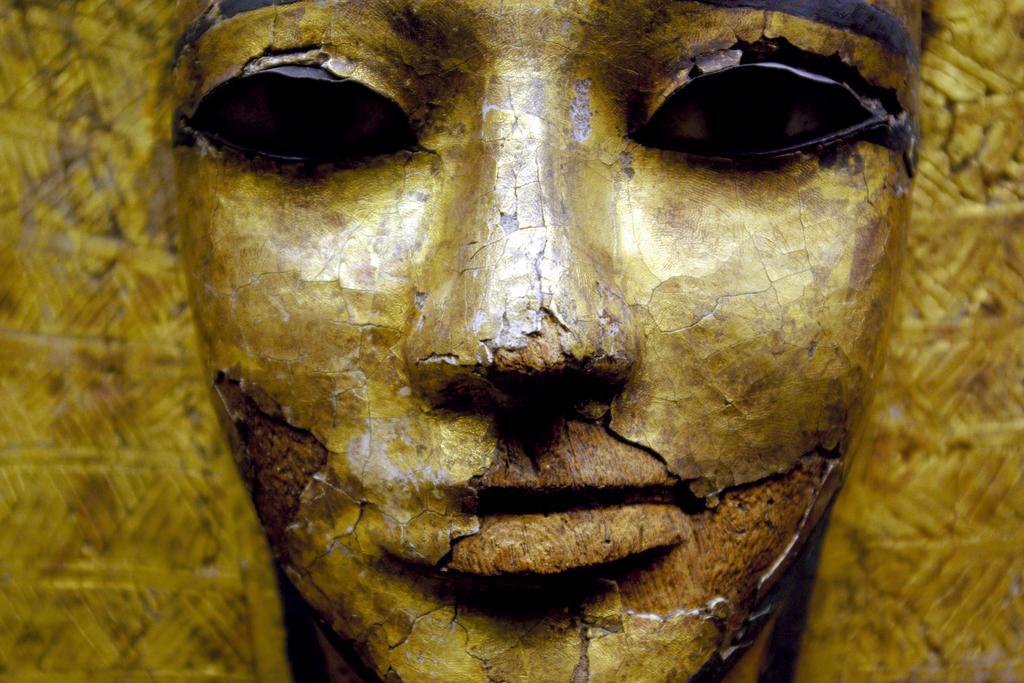How would you summarize this image in a sentence or two? In this image there is a sculpture. 